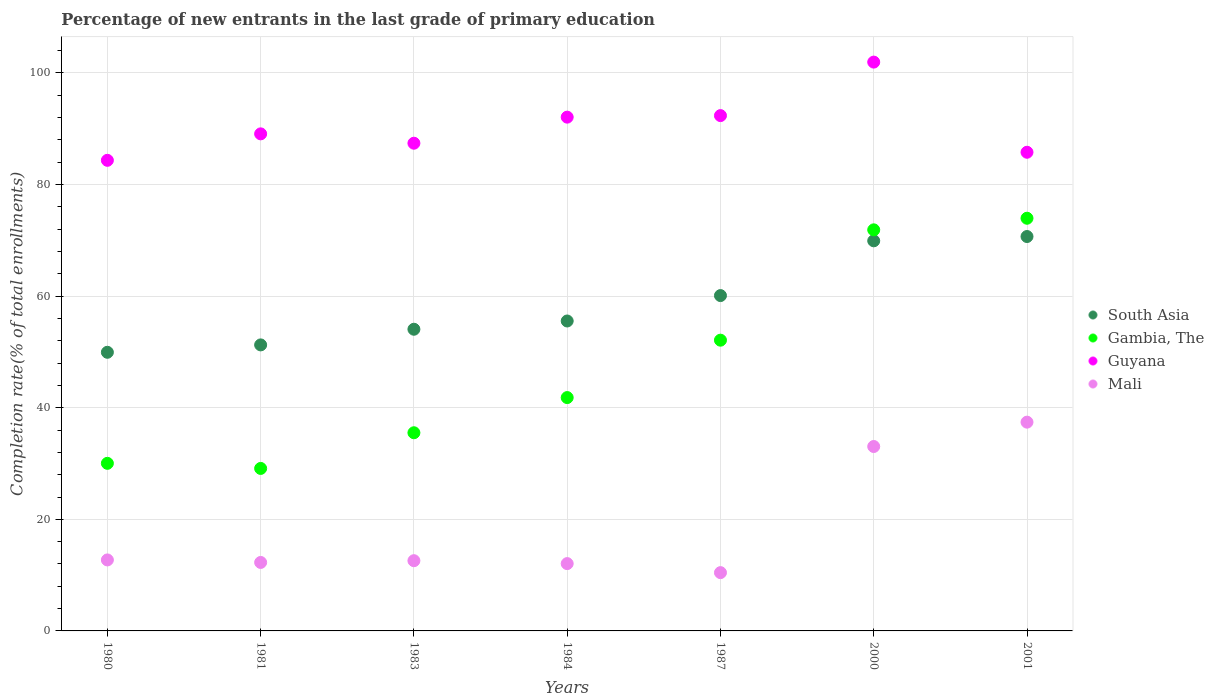How many different coloured dotlines are there?
Provide a succinct answer. 4. What is the percentage of new entrants in Gambia, The in 1987?
Your answer should be very brief. 52.11. Across all years, what is the maximum percentage of new entrants in Gambia, The?
Provide a succinct answer. 73.96. Across all years, what is the minimum percentage of new entrants in South Asia?
Keep it short and to the point. 49.94. In which year was the percentage of new entrants in Mali minimum?
Your answer should be compact. 1987. What is the total percentage of new entrants in South Asia in the graph?
Provide a succinct answer. 411.51. What is the difference between the percentage of new entrants in Guyana in 1980 and that in 1983?
Provide a short and direct response. -3.07. What is the difference between the percentage of new entrants in Gambia, The in 1984 and the percentage of new entrants in South Asia in 1980?
Make the answer very short. -8.12. What is the average percentage of new entrants in Gambia, The per year?
Offer a terse response. 47.78. In the year 2001, what is the difference between the percentage of new entrants in Guyana and percentage of new entrants in South Asia?
Your response must be concise. 15.1. In how many years, is the percentage of new entrants in South Asia greater than 8 %?
Your answer should be compact. 7. What is the ratio of the percentage of new entrants in Mali in 1980 to that in 2001?
Your response must be concise. 0.34. Is the difference between the percentage of new entrants in Guyana in 1983 and 2001 greater than the difference between the percentage of new entrants in South Asia in 1983 and 2001?
Offer a terse response. Yes. What is the difference between the highest and the second highest percentage of new entrants in South Asia?
Give a very brief answer. 0.77. What is the difference between the highest and the lowest percentage of new entrants in Gambia, The?
Keep it short and to the point. 44.84. Is the sum of the percentage of new entrants in Gambia, The in 1980 and 1983 greater than the maximum percentage of new entrants in Guyana across all years?
Your answer should be compact. No. Does the percentage of new entrants in Mali monotonically increase over the years?
Provide a succinct answer. No. Is the percentage of new entrants in Guyana strictly less than the percentage of new entrants in Mali over the years?
Your answer should be compact. No. How many dotlines are there?
Keep it short and to the point. 4. What is the difference between two consecutive major ticks on the Y-axis?
Your response must be concise. 20. What is the title of the graph?
Your answer should be compact. Percentage of new entrants in the last grade of primary education. What is the label or title of the X-axis?
Keep it short and to the point. Years. What is the label or title of the Y-axis?
Your answer should be very brief. Completion rate(% of total enrollments). What is the Completion rate(% of total enrollments) in South Asia in 1980?
Give a very brief answer. 49.94. What is the Completion rate(% of total enrollments) in Gambia, The in 1980?
Your response must be concise. 30.04. What is the Completion rate(% of total enrollments) of Guyana in 1980?
Ensure brevity in your answer.  84.34. What is the Completion rate(% of total enrollments) in Mali in 1980?
Offer a very short reply. 12.72. What is the Completion rate(% of total enrollments) of South Asia in 1981?
Your answer should be very brief. 51.26. What is the Completion rate(% of total enrollments) of Gambia, The in 1981?
Your answer should be compact. 29.12. What is the Completion rate(% of total enrollments) of Guyana in 1981?
Keep it short and to the point. 89.08. What is the Completion rate(% of total enrollments) in Mali in 1981?
Provide a succinct answer. 12.27. What is the Completion rate(% of total enrollments) of South Asia in 1983?
Ensure brevity in your answer.  54.07. What is the Completion rate(% of total enrollments) in Gambia, The in 1983?
Your answer should be very brief. 35.52. What is the Completion rate(% of total enrollments) of Guyana in 1983?
Your answer should be compact. 87.41. What is the Completion rate(% of total enrollments) of Mali in 1983?
Your answer should be very brief. 12.59. What is the Completion rate(% of total enrollments) in South Asia in 1984?
Offer a terse response. 55.55. What is the Completion rate(% of total enrollments) in Gambia, The in 1984?
Provide a short and direct response. 41.82. What is the Completion rate(% of total enrollments) of Guyana in 1984?
Your answer should be very brief. 92.08. What is the Completion rate(% of total enrollments) in Mali in 1984?
Your answer should be very brief. 12.06. What is the Completion rate(% of total enrollments) of South Asia in 1987?
Offer a terse response. 60.1. What is the Completion rate(% of total enrollments) of Gambia, The in 1987?
Offer a terse response. 52.11. What is the Completion rate(% of total enrollments) in Guyana in 1987?
Provide a short and direct response. 92.35. What is the Completion rate(% of total enrollments) of Mali in 1987?
Give a very brief answer. 10.45. What is the Completion rate(% of total enrollments) of South Asia in 2000?
Make the answer very short. 69.92. What is the Completion rate(% of total enrollments) of Gambia, The in 2000?
Give a very brief answer. 71.88. What is the Completion rate(% of total enrollments) in Guyana in 2000?
Make the answer very short. 101.94. What is the Completion rate(% of total enrollments) of Mali in 2000?
Provide a succinct answer. 33.05. What is the Completion rate(% of total enrollments) of South Asia in 2001?
Your answer should be very brief. 70.68. What is the Completion rate(% of total enrollments) of Gambia, The in 2001?
Your answer should be very brief. 73.96. What is the Completion rate(% of total enrollments) in Guyana in 2001?
Your response must be concise. 85.79. What is the Completion rate(% of total enrollments) in Mali in 2001?
Keep it short and to the point. 37.41. Across all years, what is the maximum Completion rate(% of total enrollments) of South Asia?
Ensure brevity in your answer.  70.68. Across all years, what is the maximum Completion rate(% of total enrollments) of Gambia, The?
Provide a succinct answer. 73.96. Across all years, what is the maximum Completion rate(% of total enrollments) of Guyana?
Keep it short and to the point. 101.94. Across all years, what is the maximum Completion rate(% of total enrollments) of Mali?
Your answer should be very brief. 37.41. Across all years, what is the minimum Completion rate(% of total enrollments) of South Asia?
Provide a succinct answer. 49.94. Across all years, what is the minimum Completion rate(% of total enrollments) of Gambia, The?
Make the answer very short. 29.12. Across all years, what is the minimum Completion rate(% of total enrollments) of Guyana?
Provide a short and direct response. 84.34. Across all years, what is the minimum Completion rate(% of total enrollments) of Mali?
Your answer should be compact. 10.45. What is the total Completion rate(% of total enrollments) in South Asia in the graph?
Provide a short and direct response. 411.51. What is the total Completion rate(% of total enrollments) in Gambia, The in the graph?
Give a very brief answer. 334.44. What is the total Completion rate(% of total enrollments) in Guyana in the graph?
Make the answer very short. 632.99. What is the total Completion rate(% of total enrollments) of Mali in the graph?
Offer a terse response. 130.56. What is the difference between the Completion rate(% of total enrollments) in South Asia in 1980 and that in 1981?
Your response must be concise. -1.32. What is the difference between the Completion rate(% of total enrollments) of Gambia, The in 1980 and that in 1981?
Provide a short and direct response. 0.92. What is the difference between the Completion rate(% of total enrollments) of Guyana in 1980 and that in 1981?
Your answer should be compact. -4.74. What is the difference between the Completion rate(% of total enrollments) in Mali in 1980 and that in 1981?
Provide a succinct answer. 0.45. What is the difference between the Completion rate(% of total enrollments) in South Asia in 1980 and that in 1983?
Provide a succinct answer. -4.13. What is the difference between the Completion rate(% of total enrollments) in Gambia, The in 1980 and that in 1983?
Offer a terse response. -5.48. What is the difference between the Completion rate(% of total enrollments) in Guyana in 1980 and that in 1983?
Make the answer very short. -3.07. What is the difference between the Completion rate(% of total enrollments) in Mali in 1980 and that in 1983?
Your answer should be very brief. 0.14. What is the difference between the Completion rate(% of total enrollments) of South Asia in 1980 and that in 1984?
Keep it short and to the point. -5.61. What is the difference between the Completion rate(% of total enrollments) in Gambia, The in 1980 and that in 1984?
Provide a succinct answer. -11.78. What is the difference between the Completion rate(% of total enrollments) of Guyana in 1980 and that in 1984?
Offer a very short reply. -7.74. What is the difference between the Completion rate(% of total enrollments) of Mali in 1980 and that in 1984?
Provide a short and direct response. 0.66. What is the difference between the Completion rate(% of total enrollments) of South Asia in 1980 and that in 1987?
Provide a succinct answer. -10.16. What is the difference between the Completion rate(% of total enrollments) of Gambia, The in 1980 and that in 1987?
Keep it short and to the point. -22.07. What is the difference between the Completion rate(% of total enrollments) of Guyana in 1980 and that in 1987?
Make the answer very short. -8.01. What is the difference between the Completion rate(% of total enrollments) of Mali in 1980 and that in 1987?
Provide a short and direct response. 2.28. What is the difference between the Completion rate(% of total enrollments) of South Asia in 1980 and that in 2000?
Ensure brevity in your answer.  -19.98. What is the difference between the Completion rate(% of total enrollments) in Gambia, The in 1980 and that in 2000?
Offer a terse response. -41.85. What is the difference between the Completion rate(% of total enrollments) in Guyana in 1980 and that in 2000?
Provide a short and direct response. -17.6. What is the difference between the Completion rate(% of total enrollments) of Mali in 1980 and that in 2000?
Your response must be concise. -20.33. What is the difference between the Completion rate(% of total enrollments) in South Asia in 1980 and that in 2001?
Offer a very short reply. -20.75. What is the difference between the Completion rate(% of total enrollments) in Gambia, The in 1980 and that in 2001?
Make the answer very short. -43.92. What is the difference between the Completion rate(% of total enrollments) of Guyana in 1980 and that in 2001?
Give a very brief answer. -1.45. What is the difference between the Completion rate(% of total enrollments) of Mali in 1980 and that in 2001?
Your response must be concise. -24.69. What is the difference between the Completion rate(% of total enrollments) of South Asia in 1981 and that in 1983?
Offer a very short reply. -2.8. What is the difference between the Completion rate(% of total enrollments) of Gambia, The in 1981 and that in 1983?
Offer a terse response. -6.39. What is the difference between the Completion rate(% of total enrollments) of Guyana in 1981 and that in 1983?
Make the answer very short. 1.68. What is the difference between the Completion rate(% of total enrollments) of Mali in 1981 and that in 1983?
Your answer should be compact. -0.31. What is the difference between the Completion rate(% of total enrollments) of South Asia in 1981 and that in 1984?
Keep it short and to the point. -4.29. What is the difference between the Completion rate(% of total enrollments) in Gambia, The in 1981 and that in 1984?
Offer a very short reply. -12.7. What is the difference between the Completion rate(% of total enrollments) of Guyana in 1981 and that in 1984?
Provide a short and direct response. -3. What is the difference between the Completion rate(% of total enrollments) in Mali in 1981 and that in 1984?
Make the answer very short. 0.21. What is the difference between the Completion rate(% of total enrollments) in South Asia in 1981 and that in 1987?
Make the answer very short. -8.84. What is the difference between the Completion rate(% of total enrollments) of Gambia, The in 1981 and that in 1987?
Offer a very short reply. -22.99. What is the difference between the Completion rate(% of total enrollments) of Guyana in 1981 and that in 1987?
Your answer should be compact. -3.27. What is the difference between the Completion rate(% of total enrollments) of Mali in 1981 and that in 1987?
Your answer should be very brief. 1.83. What is the difference between the Completion rate(% of total enrollments) in South Asia in 1981 and that in 2000?
Make the answer very short. -18.65. What is the difference between the Completion rate(% of total enrollments) in Gambia, The in 1981 and that in 2000?
Your response must be concise. -42.76. What is the difference between the Completion rate(% of total enrollments) in Guyana in 1981 and that in 2000?
Ensure brevity in your answer.  -12.86. What is the difference between the Completion rate(% of total enrollments) of Mali in 1981 and that in 2000?
Your answer should be compact. -20.78. What is the difference between the Completion rate(% of total enrollments) in South Asia in 1981 and that in 2001?
Give a very brief answer. -19.42. What is the difference between the Completion rate(% of total enrollments) of Gambia, The in 1981 and that in 2001?
Your answer should be compact. -44.84. What is the difference between the Completion rate(% of total enrollments) of Guyana in 1981 and that in 2001?
Keep it short and to the point. 3.3. What is the difference between the Completion rate(% of total enrollments) of Mali in 1981 and that in 2001?
Make the answer very short. -25.14. What is the difference between the Completion rate(% of total enrollments) in South Asia in 1983 and that in 1984?
Make the answer very short. -1.48. What is the difference between the Completion rate(% of total enrollments) in Gambia, The in 1983 and that in 1984?
Your response must be concise. -6.31. What is the difference between the Completion rate(% of total enrollments) of Guyana in 1983 and that in 1984?
Your response must be concise. -4.67. What is the difference between the Completion rate(% of total enrollments) of Mali in 1983 and that in 1984?
Offer a terse response. 0.52. What is the difference between the Completion rate(% of total enrollments) of South Asia in 1983 and that in 1987?
Offer a terse response. -6.03. What is the difference between the Completion rate(% of total enrollments) of Gambia, The in 1983 and that in 1987?
Ensure brevity in your answer.  -16.59. What is the difference between the Completion rate(% of total enrollments) in Guyana in 1983 and that in 1987?
Provide a short and direct response. -4.95. What is the difference between the Completion rate(% of total enrollments) in Mali in 1983 and that in 1987?
Give a very brief answer. 2.14. What is the difference between the Completion rate(% of total enrollments) in South Asia in 1983 and that in 2000?
Offer a terse response. -15.85. What is the difference between the Completion rate(% of total enrollments) in Gambia, The in 1983 and that in 2000?
Keep it short and to the point. -36.37. What is the difference between the Completion rate(% of total enrollments) of Guyana in 1983 and that in 2000?
Make the answer very short. -14.54. What is the difference between the Completion rate(% of total enrollments) in Mali in 1983 and that in 2000?
Offer a very short reply. -20.46. What is the difference between the Completion rate(% of total enrollments) in South Asia in 1983 and that in 2001?
Ensure brevity in your answer.  -16.62. What is the difference between the Completion rate(% of total enrollments) of Gambia, The in 1983 and that in 2001?
Make the answer very short. -38.44. What is the difference between the Completion rate(% of total enrollments) of Guyana in 1983 and that in 2001?
Offer a terse response. 1.62. What is the difference between the Completion rate(% of total enrollments) of Mali in 1983 and that in 2001?
Give a very brief answer. -24.83. What is the difference between the Completion rate(% of total enrollments) of South Asia in 1984 and that in 1987?
Offer a terse response. -4.55. What is the difference between the Completion rate(% of total enrollments) of Gambia, The in 1984 and that in 1987?
Provide a succinct answer. -10.29. What is the difference between the Completion rate(% of total enrollments) of Guyana in 1984 and that in 1987?
Provide a succinct answer. -0.28. What is the difference between the Completion rate(% of total enrollments) in Mali in 1984 and that in 1987?
Your answer should be compact. 1.62. What is the difference between the Completion rate(% of total enrollments) of South Asia in 1984 and that in 2000?
Your answer should be compact. -14.37. What is the difference between the Completion rate(% of total enrollments) in Gambia, The in 1984 and that in 2000?
Provide a succinct answer. -30.06. What is the difference between the Completion rate(% of total enrollments) of Guyana in 1984 and that in 2000?
Keep it short and to the point. -9.86. What is the difference between the Completion rate(% of total enrollments) of Mali in 1984 and that in 2000?
Offer a very short reply. -20.99. What is the difference between the Completion rate(% of total enrollments) of South Asia in 1984 and that in 2001?
Offer a very short reply. -15.14. What is the difference between the Completion rate(% of total enrollments) of Gambia, The in 1984 and that in 2001?
Give a very brief answer. -32.14. What is the difference between the Completion rate(% of total enrollments) in Guyana in 1984 and that in 2001?
Provide a short and direct response. 6.29. What is the difference between the Completion rate(% of total enrollments) in Mali in 1984 and that in 2001?
Your answer should be very brief. -25.35. What is the difference between the Completion rate(% of total enrollments) in South Asia in 1987 and that in 2000?
Provide a succinct answer. -9.82. What is the difference between the Completion rate(% of total enrollments) of Gambia, The in 1987 and that in 2000?
Provide a short and direct response. -19.78. What is the difference between the Completion rate(% of total enrollments) of Guyana in 1987 and that in 2000?
Offer a very short reply. -9.59. What is the difference between the Completion rate(% of total enrollments) in Mali in 1987 and that in 2000?
Give a very brief answer. -22.6. What is the difference between the Completion rate(% of total enrollments) of South Asia in 1987 and that in 2001?
Offer a very short reply. -10.59. What is the difference between the Completion rate(% of total enrollments) in Gambia, The in 1987 and that in 2001?
Make the answer very short. -21.85. What is the difference between the Completion rate(% of total enrollments) in Guyana in 1987 and that in 2001?
Provide a succinct answer. 6.57. What is the difference between the Completion rate(% of total enrollments) of Mali in 1987 and that in 2001?
Provide a short and direct response. -26.97. What is the difference between the Completion rate(% of total enrollments) of South Asia in 2000 and that in 2001?
Provide a short and direct response. -0.77. What is the difference between the Completion rate(% of total enrollments) in Gambia, The in 2000 and that in 2001?
Provide a succinct answer. -2.08. What is the difference between the Completion rate(% of total enrollments) in Guyana in 2000 and that in 2001?
Provide a succinct answer. 16.16. What is the difference between the Completion rate(% of total enrollments) in Mali in 2000 and that in 2001?
Your answer should be very brief. -4.36. What is the difference between the Completion rate(% of total enrollments) in South Asia in 1980 and the Completion rate(% of total enrollments) in Gambia, The in 1981?
Your response must be concise. 20.82. What is the difference between the Completion rate(% of total enrollments) of South Asia in 1980 and the Completion rate(% of total enrollments) of Guyana in 1981?
Your answer should be very brief. -39.15. What is the difference between the Completion rate(% of total enrollments) in South Asia in 1980 and the Completion rate(% of total enrollments) in Mali in 1981?
Provide a succinct answer. 37.66. What is the difference between the Completion rate(% of total enrollments) of Gambia, The in 1980 and the Completion rate(% of total enrollments) of Guyana in 1981?
Offer a terse response. -59.05. What is the difference between the Completion rate(% of total enrollments) of Gambia, The in 1980 and the Completion rate(% of total enrollments) of Mali in 1981?
Your answer should be compact. 17.76. What is the difference between the Completion rate(% of total enrollments) of Guyana in 1980 and the Completion rate(% of total enrollments) of Mali in 1981?
Offer a terse response. 72.07. What is the difference between the Completion rate(% of total enrollments) of South Asia in 1980 and the Completion rate(% of total enrollments) of Gambia, The in 1983?
Your answer should be very brief. 14.42. What is the difference between the Completion rate(% of total enrollments) in South Asia in 1980 and the Completion rate(% of total enrollments) in Guyana in 1983?
Offer a terse response. -37.47. What is the difference between the Completion rate(% of total enrollments) of South Asia in 1980 and the Completion rate(% of total enrollments) of Mali in 1983?
Provide a succinct answer. 37.35. What is the difference between the Completion rate(% of total enrollments) in Gambia, The in 1980 and the Completion rate(% of total enrollments) in Guyana in 1983?
Ensure brevity in your answer.  -57.37. What is the difference between the Completion rate(% of total enrollments) in Gambia, The in 1980 and the Completion rate(% of total enrollments) in Mali in 1983?
Keep it short and to the point. 17.45. What is the difference between the Completion rate(% of total enrollments) in Guyana in 1980 and the Completion rate(% of total enrollments) in Mali in 1983?
Provide a succinct answer. 71.76. What is the difference between the Completion rate(% of total enrollments) of South Asia in 1980 and the Completion rate(% of total enrollments) of Gambia, The in 1984?
Ensure brevity in your answer.  8.12. What is the difference between the Completion rate(% of total enrollments) of South Asia in 1980 and the Completion rate(% of total enrollments) of Guyana in 1984?
Provide a succinct answer. -42.14. What is the difference between the Completion rate(% of total enrollments) of South Asia in 1980 and the Completion rate(% of total enrollments) of Mali in 1984?
Provide a short and direct response. 37.87. What is the difference between the Completion rate(% of total enrollments) of Gambia, The in 1980 and the Completion rate(% of total enrollments) of Guyana in 1984?
Give a very brief answer. -62.04. What is the difference between the Completion rate(% of total enrollments) of Gambia, The in 1980 and the Completion rate(% of total enrollments) of Mali in 1984?
Keep it short and to the point. 17.97. What is the difference between the Completion rate(% of total enrollments) of Guyana in 1980 and the Completion rate(% of total enrollments) of Mali in 1984?
Give a very brief answer. 72.28. What is the difference between the Completion rate(% of total enrollments) of South Asia in 1980 and the Completion rate(% of total enrollments) of Gambia, The in 1987?
Your response must be concise. -2.17. What is the difference between the Completion rate(% of total enrollments) of South Asia in 1980 and the Completion rate(% of total enrollments) of Guyana in 1987?
Keep it short and to the point. -42.42. What is the difference between the Completion rate(% of total enrollments) of South Asia in 1980 and the Completion rate(% of total enrollments) of Mali in 1987?
Give a very brief answer. 39.49. What is the difference between the Completion rate(% of total enrollments) in Gambia, The in 1980 and the Completion rate(% of total enrollments) in Guyana in 1987?
Your response must be concise. -62.32. What is the difference between the Completion rate(% of total enrollments) of Gambia, The in 1980 and the Completion rate(% of total enrollments) of Mali in 1987?
Your response must be concise. 19.59. What is the difference between the Completion rate(% of total enrollments) of Guyana in 1980 and the Completion rate(% of total enrollments) of Mali in 1987?
Provide a succinct answer. 73.89. What is the difference between the Completion rate(% of total enrollments) of South Asia in 1980 and the Completion rate(% of total enrollments) of Gambia, The in 2000?
Your answer should be compact. -21.95. What is the difference between the Completion rate(% of total enrollments) in South Asia in 1980 and the Completion rate(% of total enrollments) in Guyana in 2000?
Your response must be concise. -52.01. What is the difference between the Completion rate(% of total enrollments) of South Asia in 1980 and the Completion rate(% of total enrollments) of Mali in 2000?
Your answer should be compact. 16.89. What is the difference between the Completion rate(% of total enrollments) of Gambia, The in 1980 and the Completion rate(% of total enrollments) of Guyana in 2000?
Make the answer very short. -71.91. What is the difference between the Completion rate(% of total enrollments) of Gambia, The in 1980 and the Completion rate(% of total enrollments) of Mali in 2000?
Your answer should be compact. -3.01. What is the difference between the Completion rate(% of total enrollments) of Guyana in 1980 and the Completion rate(% of total enrollments) of Mali in 2000?
Make the answer very short. 51.29. What is the difference between the Completion rate(% of total enrollments) in South Asia in 1980 and the Completion rate(% of total enrollments) in Gambia, The in 2001?
Your answer should be very brief. -24.02. What is the difference between the Completion rate(% of total enrollments) of South Asia in 1980 and the Completion rate(% of total enrollments) of Guyana in 2001?
Provide a short and direct response. -35.85. What is the difference between the Completion rate(% of total enrollments) in South Asia in 1980 and the Completion rate(% of total enrollments) in Mali in 2001?
Make the answer very short. 12.52. What is the difference between the Completion rate(% of total enrollments) of Gambia, The in 1980 and the Completion rate(% of total enrollments) of Guyana in 2001?
Your response must be concise. -55.75. What is the difference between the Completion rate(% of total enrollments) in Gambia, The in 1980 and the Completion rate(% of total enrollments) in Mali in 2001?
Keep it short and to the point. -7.38. What is the difference between the Completion rate(% of total enrollments) in Guyana in 1980 and the Completion rate(% of total enrollments) in Mali in 2001?
Your answer should be very brief. 46.93. What is the difference between the Completion rate(% of total enrollments) in South Asia in 1981 and the Completion rate(% of total enrollments) in Gambia, The in 1983?
Make the answer very short. 15.74. What is the difference between the Completion rate(% of total enrollments) in South Asia in 1981 and the Completion rate(% of total enrollments) in Guyana in 1983?
Give a very brief answer. -36.15. What is the difference between the Completion rate(% of total enrollments) in South Asia in 1981 and the Completion rate(% of total enrollments) in Mali in 1983?
Keep it short and to the point. 38.67. What is the difference between the Completion rate(% of total enrollments) of Gambia, The in 1981 and the Completion rate(% of total enrollments) of Guyana in 1983?
Offer a terse response. -58.29. What is the difference between the Completion rate(% of total enrollments) in Gambia, The in 1981 and the Completion rate(% of total enrollments) in Mali in 1983?
Your response must be concise. 16.54. What is the difference between the Completion rate(% of total enrollments) in Guyana in 1981 and the Completion rate(% of total enrollments) in Mali in 1983?
Keep it short and to the point. 76.5. What is the difference between the Completion rate(% of total enrollments) of South Asia in 1981 and the Completion rate(% of total enrollments) of Gambia, The in 1984?
Provide a short and direct response. 9.44. What is the difference between the Completion rate(% of total enrollments) of South Asia in 1981 and the Completion rate(% of total enrollments) of Guyana in 1984?
Provide a succinct answer. -40.82. What is the difference between the Completion rate(% of total enrollments) in South Asia in 1981 and the Completion rate(% of total enrollments) in Mali in 1984?
Provide a succinct answer. 39.2. What is the difference between the Completion rate(% of total enrollments) in Gambia, The in 1981 and the Completion rate(% of total enrollments) in Guyana in 1984?
Offer a very short reply. -62.96. What is the difference between the Completion rate(% of total enrollments) of Gambia, The in 1981 and the Completion rate(% of total enrollments) of Mali in 1984?
Your response must be concise. 17.06. What is the difference between the Completion rate(% of total enrollments) of Guyana in 1981 and the Completion rate(% of total enrollments) of Mali in 1984?
Make the answer very short. 77.02. What is the difference between the Completion rate(% of total enrollments) in South Asia in 1981 and the Completion rate(% of total enrollments) in Gambia, The in 1987?
Provide a short and direct response. -0.85. What is the difference between the Completion rate(% of total enrollments) of South Asia in 1981 and the Completion rate(% of total enrollments) of Guyana in 1987?
Your response must be concise. -41.09. What is the difference between the Completion rate(% of total enrollments) of South Asia in 1981 and the Completion rate(% of total enrollments) of Mali in 1987?
Your answer should be very brief. 40.81. What is the difference between the Completion rate(% of total enrollments) of Gambia, The in 1981 and the Completion rate(% of total enrollments) of Guyana in 1987?
Your answer should be very brief. -63.23. What is the difference between the Completion rate(% of total enrollments) of Gambia, The in 1981 and the Completion rate(% of total enrollments) of Mali in 1987?
Give a very brief answer. 18.67. What is the difference between the Completion rate(% of total enrollments) of Guyana in 1981 and the Completion rate(% of total enrollments) of Mali in 1987?
Offer a terse response. 78.64. What is the difference between the Completion rate(% of total enrollments) of South Asia in 1981 and the Completion rate(% of total enrollments) of Gambia, The in 2000?
Your response must be concise. -20.62. What is the difference between the Completion rate(% of total enrollments) of South Asia in 1981 and the Completion rate(% of total enrollments) of Guyana in 2000?
Provide a succinct answer. -50.68. What is the difference between the Completion rate(% of total enrollments) in South Asia in 1981 and the Completion rate(% of total enrollments) in Mali in 2000?
Offer a very short reply. 18.21. What is the difference between the Completion rate(% of total enrollments) in Gambia, The in 1981 and the Completion rate(% of total enrollments) in Guyana in 2000?
Keep it short and to the point. -72.82. What is the difference between the Completion rate(% of total enrollments) in Gambia, The in 1981 and the Completion rate(% of total enrollments) in Mali in 2000?
Offer a terse response. -3.93. What is the difference between the Completion rate(% of total enrollments) in Guyana in 1981 and the Completion rate(% of total enrollments) in Mali in 2000?
Offer a terse response. 56.03. What is the difference between the Completion rate(% of total enrollments) of South Asia in 1981 and the Completion rate(% of total enrollments) of Gambia, The in 2001?
Offer a terse response. -22.7. What is the difference between the Completion rate(% of total enrollments) of South Asia in 1981 and the Completion rate(% of total enrollments) of Guyana in 2001?
Your response must be concise. -34.53. What is the difference between the Completion rate(% of total enrollments) of South Asia in 1981 and the Completion rate(% of total enrollments) of Mali in 2001?
Ensure brevity in your answer.  13.85. What is the difference between the Completion rate(% of total enrollments) of Gambia, The in 1981 and the Completion rate(% of total enrollments) of Guyana in 2001?
Make the answer very short. -56.67. What is the difference between the Completion rate(% of total enrollments) in Gambia, The in 1981 and the Completion rate(% of total enrollments) in Mali in 2001?
Provide a succinct answer. -8.29. What is the difference between the Completion rate(% of total enrollments) of Guyana in 1981 and the Completion rate(% of total enrollments) of Mali in 2001?
Make the answer very short. 51.67. What is the difference between the Completion rate(% of total enrollments) of South Asia in 1983 and the Completion rate(% of total enrollments) of Gambia, The in 1984?
Keep it short and to the point. 12.24. What is the difference between the Completion rate(% of total enrollments) in South Asia in 1983 and the Completion rate(% of total enrollments) in Guyana in 1984?
Make the answer very short. -38.01. What is the difference between the Completion rate(% of total enrollments) of South Asia in 1983 and the Completion rate(% of total enrollments) of Mali in 1984?
Your answer should be compact. 42. What is the difference between the Completion rate(% of total enrollments) of Gambia, The in 1983 and the Completion rate(% of total enrollments) of Guyana in 1984?
Give a very brief answer. -56.56. What is the difference between the Completion rate(% of total enrollments) in Gambia, The in 1983 and the Completion rate(% of total enrollments) in Mali in 1984?
Offer a terse response. 23.45. What is the difference between the Completion rate(% of total enrollments) of Guyana in 1983 and the Completion rate(% of total enrollments) of Mali in 1984?
Provide a short and direct response. 75.34. What is the difference between the Completion rate(% of total enrollments) of South Asia in 1983 and the Completion rate(% of total enrollments) of Gambia, The in 1987?
Provide a short and direct response. 1.96. What is the difference between the Completion rate(% of total enrollments) in South Asia in 1983 and the Completion rate(% of total enrollments) in Guyana in 1987?
Make the answer very short. -38.29. What is the difference between the Completion rate(% of total enrollments) of South Asia in 1983 and the Completion rate(% of total enrollments) of Mali in 1987?
Keep it short and to the point. 43.62. What is the difference between the Completion rate(% of total enrollments) of Gambia, The in 1983 and the Completion rate(% of total enrollments) of Guyana in 1987?
Offer a terse response. -56.84. What is the difference between the Completion rate(% of total enrollments) in Gambia, The in 1983 and the Completion rate(% of total enrollments) in Mali in 1987?
Your answer should be compact. 25.07. What is the difference between the Completion rate(% of total enrollments) in Guyana in 1983 and the Completion rate(% of total enrollments) in Mali in 1987?
Provide a short and direct response. 76.96. What is the difference between the Completion rate(% of total enrollments) of South Asia in 1983 and the Completion rate(% of total enrollments) of Gambia, The in 2000?
Give a very brief answer. -17.82. What is the difference between the Completion rate(% of total enrollments) of South Asia in 1983 and the Completion rate(% of total enrollments) of Guyana in 2000?
Offer a very short reply. -47.88. What is the difference between the Completion rate(% of total enrollments) in South Asia in 1983 and the Completion rate(% of total enrollments) in Mali in 2000?
Your answer should be compact. 21.01. What is the difference between the Completion rate(% of total enrollments) in Gambia, The in 1983 and the Completion rate(% of total enrollments) in Guyana in 2000?
Your answer should be very brief. -66.43. What is the difference between the Completion rate(% of total enrollments) of Gambia, The in 1983 and the Completion rate(% of total enrollments) of Mali in 2000?
Your response must be concise. 2.47. What is the difference between the Completion rate(% of total enrollments) in Guyana in 1983 and the Completion rate(% of total enrollments) in Mali in 2000?
Your response must be concise. 54.36. What is the difference between the Completion rate(% of total enrollments) in South Asia in 1983 and the Completion rate(% of total enrollments) in Gambia, The in 2001?
Your answer should be compact. -19.89. What is the difference between the Completion rate(% of total enrollments) of South Asia in 1983 and the Completion rate(% of total enrollments) of Guyana in 2001?
Your response must be concise. -31.72. What is the difference between the Completion rate(% of total enrollments) of South Asia in 1983 and the Completion rate(% of total enrollments) of Mali in 2001?
Your answer should be compact. 16.65. What is the difference between the Completion rate(% of total enrollments) in Gambia, The in 1983 and the Completion rate(% of total enrollments) in Guyana in 2001?
Your response must be concise. -50.27. What is the difference between the Completion rate(% of total enrollments) of Gambia, The in 1983 and the Completion rate(% of total enrollments) of Mali in 2001?
Your answer should be compact. -1.9. What is the difference between the Completion rate(% of total enrollments) in Guyana in 1983 and the Completion rate(% of total enrollments) in Mali in 2001?
Make the answer very short. 49.99. What is the difference between the Completion rate(% of total enrollments) of South Asia in 1984 and the Completion rate(% of total enrollments) of Gambia, The in 1987?
Give a very brief answer. 3.44. What is the difference between the Completion rate(% of total enrollments) in South Asia in 1984 and the Completion rate(% of total enrollments) in Guyana in 1987?
Provide a succinct answer. -36.81. What is the difference between the Completion rate(% of total enrollments) in South Asia in 1984 and the Completion rate(% of total enrollments) in Mali in 1987?
Provide a short and direct response. 45.1. What is the difference between the Completion rate(% of total enrollments) in Gambia, The in 1984 and the Completion rate(% of total enrollments) in Guyana in 1987?
Offer a very short reply. -50.53. What is the difference between the Completion rate(% of total enrollments) of Gambia, The in 1984 and the Completion rate(% of total enrollments) of Mali in 1987?
Your answer should be very brief. 31.37. What is the difference between the Completion rate(% of total enrollments) of Guyana in 1984 and the Completion rate(% of total enrollments) of Mali in 1987?
Provide a short and direct response. 81.63. What is the difference between the Completion rate(% of total enrollments) in South Asia in 1984 and the Completion rate(% of total enrollments) in Gambia, The in 2000?
Give a very brief answer. -16.34. What is the difference between the Completion rate(% of total enrollments) in South Asia in 1984 and the Completion rate(% of total enrollments) in Guyana in 2000?
Provide a succinct answer. -46.4. What is the difference between the Completion rate(% of total enrollments) of South Asia in 1984 and the Completion rate(% of total enrollments) of Mali in 2000?
Offer a very short reply. 22.5. What is the difference between the Completion rate(% of total enrollments) in Gambia, The in 1984 and the Completion rate(% of total enrollments) in Guyana in 2000?
Your response must be concise. -60.12. What is the difference between the Completion rate(% of total enrollments) of Gambia, The in 1984 and the Completion rate(% of total enrollments) of Mali in 2000?
Keep it short and to the point. 8.77. What is the difference between the Completion rate(% of total enrollments) in Guyana in 1984 and the Completion rate(% of total enrollments) in Mali in 2000?
Provide a short and direct response. 59.03. What is the difference between the Completion rate(% of total enrollments) of South Asia in 1984 and the Completion rate(% of total enrollments) of Gambia, The in 2001?
Offer a very short reply. -18.41. What is the difference between the Completion rate(% of total enrollments) of South Asia in 1984 and the Completion rate(% of total enrollments) of Guyana in 2001?
Your answer should be very brief. -30.24. What is the difference between the Completion rate(% of total enrollments) of South Asia in 1984 and the Completion rate(% of total enrollments) of Mali in 2001?
Provide a succinct answer. 18.13. What is the difference between the Completion rate(% of total enrollments) of Gambia, The in 1984 and the Completion rate(% of total enrollments) of Guyana in 2001?
Provide a short and direct response. -43.97. What is the difference between the Completion rate(% of total enrollments) of Gambia, The in 1984 and the Completion rate(% of total enrollments) of Mali in 2001?
Your response must be concise. 4.41. What is the difference between the Completion rate(% of total enrollments) in Guyana in 1984 and the Completion rate(% of total enrollments) in Mali in 2001?
Provide a succinct answer. 54.66. What is the difference between the Completion rate(% of total enrollments) of South Asia in 1987 and the Completion rate(% of total enrollments) of Gambia, The in 2000?
Give a very brief answer. -11.78. What is the difference between the Completion rate(% of total enrollments) in South Asia in 1987 and the Completion rate(% of total enrollments) in Guyana in 2000?
Give a very brief answer. -41.84. What is the difference between the Completion rate(% of total enrollments) of South Asia in 1987 and the Completion rate(% of total enrollments) of Mali in 2000?
Offer a terse response. 27.05. What is the difference between the Completion rate(% of total enrollments) of Gambia, The in 1987 and the Completion rate(% of total enrollments) of Guyana in 2000?
Your response must be concise. -49.84. What is the difference between the Completion rate(% of total enrollments) in Gambia, The in 1987 and the Completion rate(% of total enrollments) in Mali in 2000?
Provide a short and direct response. 19.06. What is the difference between the Completion rate(% of total enrollments) of Guyana in 1987 and the Completion rate(% of total enrollments) of Mali in 2000?
Your answer should be very brief. 59.3. What is the difference between the Completion rate(% of total enrollments) in South Asia in 1987 and the Completion rate(% of total enrollments) in Gambia, The in 2001?
Ensure brevity in your answer.  -13.86. What is the difference between the Completion rate(% of total enrollments) in South Asia in 1987 and the Completion rate(% of total enrollments) in Guyana in 2001?
Keep it short and to the point. -25.69. What is the difference between the Completion rate(% of total enrollments) of South Asia in 1987 and the Completion rate(% of total enrollments) of Mali in 2001?
Your response must be concise. 22.68. What is the difference between the Completion rate(% of total enrollments) of Gambia, The in 1987 and the Completion rate(% of total enrollments) of Guyana in 2001?
Your answer should be compact. -33.68. What is the difference between the Completion rate(% of total enrollments) in Gambia, The in 1987 and the Completion rate(% of total enrollments) in Mali in 2001?
Provide a short and direct response. 14.69. What is the difference between the Completion rate(% of total enrollments) in Guyana in 1987 and the Completion rate(% of total enrollments) in Mali in 2001?
Your response must be concise. 54.94. What is the difference between the Completion rate(% of total enrollments) of South Asia in 2000 and the Completion rate(% of total enrollments) of Gambia, The in 2001?
Your response must be concise. -4.05. What is the difference between the Completion rate(% of total enrollments) of South Asia in 2000 and the Completion rate(% of total enrollments) of Guyana in 2001?
Ensure brevity in your answer.  -15.87. What is the difference between the Completion rate(% of total enrollments) in South Asia in 2000 and the Completion rate(% of total enrollments) in Mali in 2001?
Your answer should be compact. 32.5. What is the difference between the Completion rate(% of total enrollments) of Gambia, The in 2000 and the Completion rate(% of total enrollments) of Guyana in 2001?
Your response must be concise. -13.9. What is the difference between the Completion rate(% of total enrollments) in Gambia, The in 2000 and the Completion rate(% of total enrollments) in Mali in 2001?
Keep it short and to the point. 34.47. What is the difference between the Completion rate(% of total enrollments) of Guyana in 2000 and the Completion rate(% of total enrollments) of Mali in 2001?
Provide a short and direct response. 64.53. What is the average Completion rate(% of total enrollments) in South Asia per year?
Provide a succinct answer. 58.79. What is the average Completion rate(% of total enrollments) of Gambia, The per year?
Your answer should be very brief. 47.78. What is the average Completion rate(% of total enrollments) of Guyana per year?
Offer a terse response. 90.43. What is the average Completion rate(% of total enrollments) in Mali per year?
Your answer should be very brief. 18.65. In the year 1980, what is the difference between the Completion rate(% of total enrollments) of South Asia and Completion rate(% of total enrollments) of Gambia, The?
Your answer should be compact. 19.9. In the year 1980, what is the difference between the Completion rate(% of total enrollments) of South Asia and Completion rate(% of total enrollments) of Guyana?
Your answer should be very brief. -34.4. In the year 1980, what is the difference between the Completion rate(% of total enrollments) of South Asia and Completion rate(% of total enrollments) of Mali?
Provide a succinct answer. 37.21. In the year 1980, what is the difference between the Completion rate(% of total enrollments) of Gambia, The and Completion rate(% of total enrollments) of Guyana?
Provide a short and direct response. -54.3. In the year 1980, what is the difference between the Completion rate(% of total enrollments) of Gambia, The and Completion rate(% of total enrollments) of Mali?
Provide a succinct answer. 17.31. In the year 1980, what is the difference between the Completion rate(% of total enrollments) in Guyana and Completion rate(% of total enrollments) in Mali?
Make the answer very short. 71.62. In the year 1981, what is the difference between the Completion rate(% of total enrollments) in South Asia and Completion rate(% of total enrollments) in Gambia, The?
Offer a very short reply. 22.14. In the year 1981, what is the difference between the Completion rate(% of total enrollments) in South Asia and Completion rate(% of total enrollments) in Guyana?
Offer a very short reply. -37.82. In the year 1981, what is the difference between the Completion rate(% of total enrollments) of South Asia and Completion rate(% of total enrollments) of Mali?
Your answer should be compact. 38.99. In the year 1981, what is the difference between the Completion rate(% of total enrollments) of Gambia, The and Completion rate(% of total enrollments) of Guyana?
Your answer should be compact. -59.96. In the year 1981, what is the difference between the Completion rate(% of total enrollments) of Gambia, The and Completion rate(% of total enrollments) of Mali?
Your response must be concise. 16.85. In the year 1981, what is the difference between the Completion rate(% of total enrollments) of Guyana and Completion rate(% of total enrollments) of Mali?
Offer a terse response. 76.81. In the year 1983, what is the difference between the Completion rate(% of total enrollments) in South Asia and Completion rate(% of total enrollments) in Gambia, The?
Your answer should be very brief. 18.55. In the year 1983, what is the difference between the Completion rate(% of total enrollments) in South Asia and Completion rate(% of total enrollments) in Guyana?
Make the answer very short. -33.34. In the year 1983, what is the difference between the Completion rate(% of total enrollments) in South Asia and Completion rate(% of total enrollments) in Mali?
Offer a very short reply. 41.48. In the year 1983, what is the difference between the Completion rate(% of total enrollments) in Gambia, The and Completion rate(% of total enrollments) in Guyana?
Your answer should be very brief. -51.89. In the year 1983, what is the difference between the Completion rate(% of total enrollments) in Gambia, The and Completion rate(% of total enrollments) in Mali?
Give a very brief answer. 22.93. In the year 1983, what is the difference between the Completion rate(% of total enrollments) of Guyana and Completion rate(% of total enrollments) of Mali?
Your answer should be very brief. 74.82. In the year 1984, what is the difference between the Completion rate(% of total enrollments) of South Asia and Completion rate(% of total enrollments) of Gambia, The?
Provide a succinct answer. 13.73. In the year 1984, what is the difference between the Completion rate(% of total enrollments) in South Asia and Completion rate(% of total enrollments) in Guyana?
Provide a short and direct response. -36.53. In the year 1984, what is the difference between the Completion rate(% of total enrollments) of South Asia and Completion rate(% of total enrollments) of Mali?
Your response must be concise. 43.48. In the year 1984, what is the difference between the Completion rate(% of total enrollments) of Gambia, The and Completion rate(% of total enrollments) of Guyana?
Provide a short and direct response. -50.26. In the year 1984, what is the difference between the Completion rate(% of total enrollments) in Gambia, The and Completion rate(% of total enrollments) in Mali?
Ensure brevity in your answer.  29.76. In the year 1984, what is the difference between the Completion rate(% of total enrollments) in Guyana and Completion rate(% of total enrollments) in Mali?
Your response must be concise. 80.01. In the year 1987, what is the difference between the Completion rate(% of total enrollments) in South Asia and Completion rate(% of total enrollments) in Gambia, The?
Give a very brief answer. 7.99. In the year 1987, what is the difference between the Completion rate(% of total enrollments) of South Asia and Completion rate(% of total enrollments) of Guyana?
Your answer should be compact. -32.26. In the year 1987, what is the difference between the Completion rate(% of total enrollments) of South Asia and Completion rate(% of total enrollments) of Mali?
Provide a short and direct response. 49.65. In the year 1987, what is the difference between the Completion rate(% of total enrollments) of Gambia, The and Completion rate(% of total enrollments) of Guyana?
Ensure brevity in your answer.  -40.25. In the year 1987, what is the difference between the Completion rate(% of total enrollments) of Gambia, The and Completion rate(% of total enrollments) of Mali?
Keep it short and to the point. 41.66. In the year 1987, what is the difference between the Completion rate(% of total enrollments) in Guyana and Completion rate(% of total enrollments) in Mali?
Your answer should be compact. 81.91. In the year 2000, what is the difference between the Completion rate(% of total enrollments) of South Asia and Completion rate(% of total enrollments) of Gambia, The?
Offer a terse response. -1.97. In the year 2000, what is the difference between the Completion rate(% of total enrollments) in South Asia and Completion rate(% of total enrollments) in Guyana?
Offer a very short reply. -32.03. In the year 2000, what is the difference between the Completion rate(% of total enrollments) of South Asia and Completion rate(% of total enrollments) of Mali?
Keep it short and to the point. 36.86. In the year 2000, what is the difference between the Completion rate(% of total enrollments) in Gambia, The and Completion rate(% of total enrollments) in Guyana?
Make the answer very short. -30.06. In the year 2000, what is the difference between the Completion rate(% of total enrollments) in Gambia, The and Completion rate(% of total enrollments) in Mali?
Give a very brief answer. 38.83. In the year 2000, what is the difference between the Completion rate(% of total enrollments) in Guyana and Completion rate(% of total enrollments) in Mali?
Provide a succinct answer. 68.89. In the year 2001, what is the difference between the Completion rate(% of total enrollments) in South Asia and Completion rate(% of total enrollments) in Gambia, The?
Give a very brief answer. -3.28. In the year 2001, what is the difference between the Completion rate(% of total enrollments) of South Asia and Completion rate(% of total enrollments) of Guyana?
Keep it short and to the point. -15.1. In the year 2001, what is the difference between the Completion rate(% of total enrollments) in South Asia and Completion rate(% of total enrollments) in Mali?
Give a very brief answer. 33.27. In the year 2001, what is the difference between the Completion rate(% of total enrollments) of Gambia, The and Completion rate(% of total enrollments) of Guyana?
Your answer should be very brief. -11.83. In the year 2001, what is the difference between the Completion rate(% of total enrollments) of Gambia, The and Completion rate(% of total enrollments) of Mali?
Ensure brevity in your answer.  36.55. In the year 2001, what is the difference between the Completion rate(% of total enrollments) of Guyana and Completion rate(% of total enrollments) of Mali?
Make the answer very short. 48.37. What is the ratio of the Completion rate(% of total enrollments) of South Asia in 1980 to that in 1981?
Offer a terse response. 0.97. What is the ratio of the Completion rate(% of total enrollments) of Gambia, The in 1980 to that in 1981?
Provide a short and direct response. 1.03. What is the ratio of the Completion rate(% of total enrollments) in Guyana in 1980 to that in 1981?
Your answer should be compact. 0.95. What is the ratio of the Completion rate(% of total enrollments) in Mali in 1980 to that in 1981?
Offer a terse response. 1.04. What is the ratio of the Completion rate(% of total enrollments) in South Asia in 1980 to that in 1983?
Offer a terse response. 0.92. What is the ratio of the Completion rate(% of total enrollments) of Gambia, The in 1980 to that in 1983?
Give a very brief answer. 0.85. What is the ratio of the Completion rate(% of total enrollments) of Guyana in 1980 to that in 1983?
Provide a short and direct response. 0.96. What is the ratio of the Completion rate(% of total enrollments) of Mali in 1980 to that in 1983?
Your answer should be very brief. 1.01. What is the ratio of the Completion rate(% of total enrollments) in South Asia in 1980 to that in 1984?
Keep it short and to the point. 0.9. What is the ratio of the Completion rate(% of total enrollments) of Gambia, The in 1980 to that in 1984?
Ensure brevity in your answer.  0.72. What is the ratio of the Completion rate(% of total enrollments) of Guyana in 1980 to that in 1984?
Give a very brief answer. 0.92. What is the ratio of the Completion rate(% of total enrollments) in Mali in 1980 to that in 1984?
Your answer should be compact. 1.05. What is the ratio of the Completion rate(% of total enrollments) of South Asia in 1980 to that in 1987?
Ensure brevity in your answer.  0.83. What is the ratio of the Completion rate(% of total enrollments) of Gambia, The in 1980 to that in 1987?
Make the answer very short. 0.58. What is the ratio of the Completion rate(% of total enrollments) in Guyana in 1980 to that in 1987?
Make the answer very short. 0.91. What is the ratio of the Completion rate(% of total enrollments) of Mali in 1980 to that in 1987?
Give a very brief answer. 1.22. What is the ratio of the Completion rate(% of total enrollments) in South Asia in 1980 to that in 2000?
Provide a short and direct response. 0.71. What is the ratio of the Completion rate(% of total enrollments) in Gambia, The in 1980 to that in 2000?
Offer a terse response. 0.42. What is the ratio of the Completion rate(% of total enrollments) in Guyana in 1980 to that in 2000?
Provide a short and direct response. 0.83. What is the ratio of the Completion rate(% of total enrollments) in Mali in 1980 to that in 2000?
Make the answer very short. 0.39. What is the ratio of the Completion rate(% of total enrollments) in South Asia in 1980 to that in 2001?
Keep it short and to the point. 0.71. What is the ratio of the Completion rate(% of total enrollments) of Gambia, The in 1980 to that in 2001?
Your answer should be very brief. 0.41. What is the ratio of the Completion rate(% of total enrollments) of Guyana in 1980 to that in 2001?
Offer a very short reply. 0.98. What is the ratio of the Completion rate(% of total enrollments) of Mali in 1980 to that in 2001?
Offer a terse response. 0.34. What is the ratio of the Completion rate(% of total enrollments) of South Asia in 1981 to that in 1983?
Offer a very short reply. 0.95. What is the ratio of the Completion rate(% of total enrollments) of Gambia, The in 1981 to that in 1983?
Offer a very short reply. 0.82. What is the ratio of the Completion rate(% of total enrollments) of Guyana in 1981 to that in 1983?
Provide a succinct answer. 1.02. What is the ratio of the Completion rate(% of total enrollments) in Mali in 1981 to that in 1983?
Offer a terse response. 0.98. What is the ratio of the Completion rate(% of total enrollments) of South Asia in 1981 to that in 1984?
Provide a short and direct response. 0.92. What is the ratio of the Completion rate(% of total enrollments) of Gambia, The in 1981 to that in 1984?
Your response must be concise. 0.7. What is the ratio of the Completion rate(% of total enrollments) in Guyana in 1981 to that in 1984?
Keep it short and to the point. 0.97. What is the ratio of the Completion rate(% of total enrollments) in Mali in 1981 to that in 1984?
Give a very brief answer. 1.02. What is the ratio of the Completion rate(% of total enrollments) of South Asia in 1981 to that in 1987?
Provide a short and direct response. 0.85. What is the ratio of the Completion rate(% of total enrollments) of Gambia, The in 1981 to that in 1987?
Give a very brief answer. 0.56. What is the ratio of the Completion rate(% of total enrollments) of Guyana in 1981 to that in 1987?
Offer a terse response. 0.96. What is the ratio of the Completion rate(% of total enrollments) in Mali in 1981 to that in 1987?
Provide a short and direct response. 1.17. What is the ratio of the Completion rate(% of total enrollments) of South Asia in 1981 to that in 2000?
Provide a short and direct response. 0.73. What is the ratio of the Completion rate(% of total enrollments) in Gambia, The in 1981 to that in 2000?
Your answer should be very brief. 0.41. What is the ratio of the Completion rate(% of total enrollments) of Guyana in 1981 to that in 2000?
Make the answer very short. 0.87. What is the ratio of the Completion rate(% of total enrollments) of Mali in 1981 to that in 2000?
Ensure brevity in your answer.  0.37. What is the ratio of the Completion rate(% of total enrollments) in South Asia in 1981 to that in 2001?
Your response must be concise. 0.73. What is the ratio of the Completion rate(% of total enrollments) in Gambia, The in 1981 to that in 2001?
Offer a very short reply. 0.39. What is the ratio of the Completion rate(% of total enrollments) of Guyana in 1981 to that in 2001?
Provide a short and direct response. 1.04. What is the ratio of the Completion rate(% of total enrollments) of Mali in 1981 to that in 2001?
Make the answer very short. 0.33. What is the ratio of the Completion rate(% of total enrollments) of South Asia in 1983 to that in 1984?
Give a very brief answer. 0.97. What is the ratio of the Completion rate(% of total enrollments) of Gambia, The in 1983 to that in 1984?
Ensure brevity in your answer.  0.85. What is the ratio of the Completion rate(% of total enrollments) in Guyana in 1983 to that in 1984?
Your answer should be compact. 0.95. What is the ratio of the Completion rate(% of total enrollments) of Mali in 1983 to that in 1984?
Provide a short and direct response. 1.04. What is the ratio of the Completion rate(% of total enrollments) of South Asia in 1983 to that in 1987?
Provide a succinct answer. 0.9. What is the ratio of the Completion rate(% of total enrollments) in Gambia, The in 1983 to that in 1987?
Offer a terse response. 0.68. What is the ratio of the Completion rate(% of total enrollments) in Guyana in 1983 to that in 1987?
Your response must be concise. 0.95. What is the ratio of the Completion rate(% of total enrollments) in Mali in 1983 to that in 1987?
Provide a short and direct response. 1.2. What is the ratio of the Completion rate(% of total enrollments) in South Asia in 1983 to that in 2000?
Your answer should be very brief. 0.77. What is the ratio of the Completion rate(% of total enrollments) of Gambia, The in 1983 to that in 2000?
Keep it short and to the point. 0.49. What is the ratio of the Completion rate(% of total enrollments) of Guyana in 1983 to that in 2000?
Make the answer very short. 0.86. What is the ratio of the Completion rate(% of total enrollments) of Mali in 1983 to that in 2000?
Offer a terse response. 0.38. What is the ratio of the Completion rate(% of total enrollments) of South Asia in 1983 to that in 2001?
Keep it short and to the point. 0.76. What is the ratio of the Completion rate(% of total enrollments) of Gambia, The in 1983 to that in 2001?
Offer a very short reply. 0.48. What is the ratio of the Completion rate(% of total enrollments) of Guyana in 1983 to that in 2001?
Provide a short and direct response. 1.02. What is the ratio of the Completion rate(% of total enrollments) of Mali in 1983 to that in 2001?
Keep it short and to the point. 0.34. What is the ratio of the Completion rate(% of total enrollments) of South Asia in 1984 to that in 1987?
Offer a terse response. 0.92. What is the ratio of the Completion rate(% of total enrollments) in Gambia, The in 1984 to that in 1987?
Give a very brief answer. 0.8. What is the ratio of the Completion rate(% of total enrollments) in Guyana in 1984 to that in 1987?
Your response must be concise. 1. What is the ratio of the Completion rate(% of total enrollments) of Mali in 1984 to that in 1987?
Ensure brevity in your answer.  1.15. What is the ratio of the Completion rate(% of total enrollments) of South Asia in 1984 to that in 2000?
Give a very brief answer. 0.79. What is the ratio of the Completion rate(% of total enrollments) in Gambia, The in 1984 to that in 2000?
Make the answer very short. 0.58. What is the ratio of the Completion rate(% of total enrollments) in Guyana in 1984 to that in 2000?
Provide a succinct answer. 0.9. What is the ratio of the Completion rate(% of total enrollments) of Mali in 1984 to that in 2000?
Keep it short and to the point. 0.36. What is the ratio of the Completion rate(% of total enrollments) in South Asia in 1984 to that in 2001?
Provide a short and direct response. 0.79. What is the ratio of the Completion rate(% of total enrollments) of Gambia, The in 1984 to that in 2001?
Your answer should be compact. 0.57. What is the ratio of the Completion rate(% of total enrollments) in Guyana in 1984 to that in 2001?
Offer a very short reply. 1.07. What is the ratio of the Completion rate(% of total enrollments) in Mali in 1984 to that in 2001?
Provide a short and direct response. 0.32. What is the ratio of the Completion rate(% of total enrollments) in South Asia in 1987 to that in 2000?
Your answer should be very brief. 0.86. What is the ratio of the Completion rate(% of total enrollments) in Gambia, The in 1987 to that in 2000?
Offer a terse response. 0.72. What is the ratio of the Completion rate(% of total enrollments) in Guyana in 1987 to that in 2000?
Your answer should be very brief. 0.91. What is the ratio of the Completion rate(% of total enrollments) in Mali in 1987 to that in 2000?
Provide a short and direct response. 0.32. What is the ratio of the Completion rate(% of total enrollments) in South Asia in 1987 to that in 2001?
Your answer should be very brief. 0.85. What is the ratio of the Completion rate(% of total enrollments) of Gambia, The in 1987 to that in 2001?
Give a very brief answer. 0.7. What is the ratio of the Completion rate(% of total enrollments) of Guyana in 1987 to that in 2001?
Offer a very short reply. 1.08. What is the ratio of the Completion rate(% of total enrollments) in Mali in 1987 to that in 2001?
Provide a short and direct response. 0.28. What is the ratio of the Completion rate(% of total enrollments) of South Asia in 2000 to that in 2001?
Offer a very short reply. 0.99. What is the ratio of the Completion rate(% of total enrollments) of Gambia, The in 2000 to that in 2001?
Give a very brief answer. 0.97. What is the ratio of the Completion rate(% of total enrollments) in Guyana in 2000 to that in 2001?
Ensure brevity in your answer.  1.19. What is the ratio of the Completion rate(% of total enrollments) in Mali in 2000 to that in 2001?
Offer a very short reply. 0.88. What is the difference between the highest and the second highest Completion rate(% of total enrollments) of South Asia?
Provide a short and direct response. 0.77. What is the difference between the highest and the second highest Completion rate(% of total enrollments) of Gambia, The?
Ensure brevity in your answer.  2.08. What is the difference between the highest and the second highest Completion rate(% of total enrollments) of Guyana?
Provide a succinct answer. 9.59. What is the difference between the highest and the second highest Completion rate(% of total enrollments) in Mali?
Your answer should be compact. 4.36. What is the difference between the highest and the lowest Completion rate(% of total enrollments) of South Asia?
Offer a terse response. 20.75. What is the difference between the highest and the lowest Completion rate(% of total enrollments) of Gambia, The?
Ensure brevity in your answer.  44.84. What is the difference between the highest and the lowest Completion rate(% of total enrollments) in Guyana?
Offer a terse response. 17.6. What is the difference between the highest and the lowest Completion rate(% of total enrollments) in Mali?
Provide a succinct answer. 26.97. 